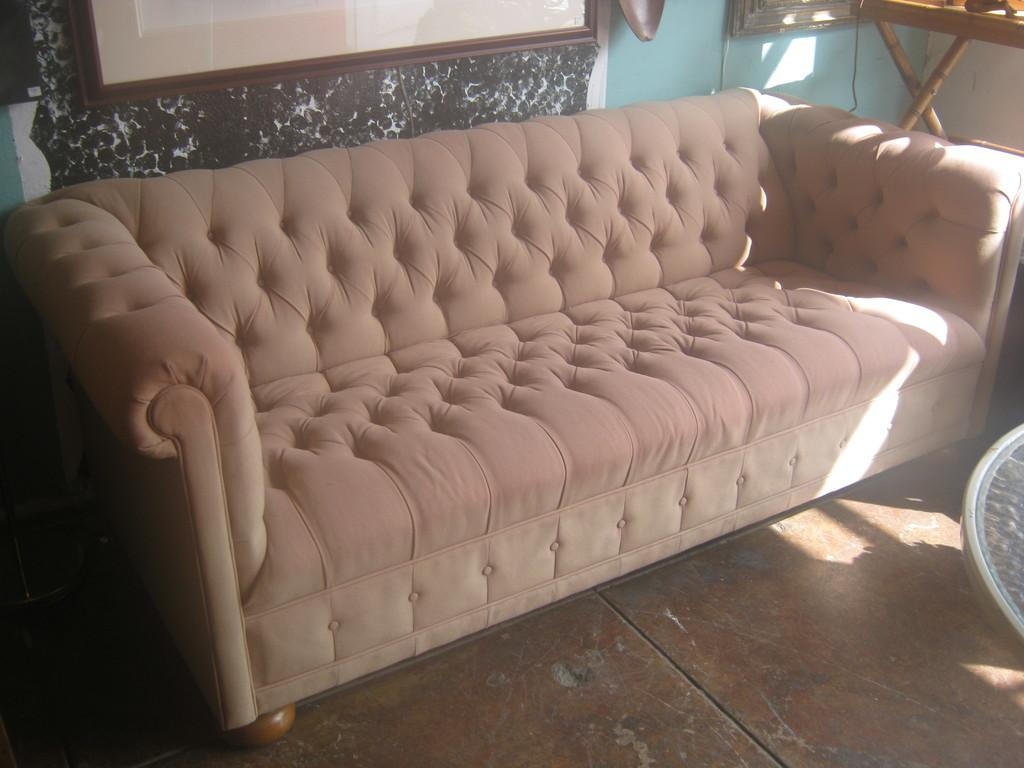Where was the image taken? The image was taken in a room. What furniture is present in the room? There is a sofa in the room. What is behind the sofa? There is a wall behind the sofa. What other piece of furniture can be seen on the right side of the image? There is a wooden table on the right side of the image. Can you see any twigs on the wooden table in the image? There are no twigs visible on the wooden table in the image. Is there a basketball game happening in the room in the image? There is no basketball game or any reference to a basketball in the image. 